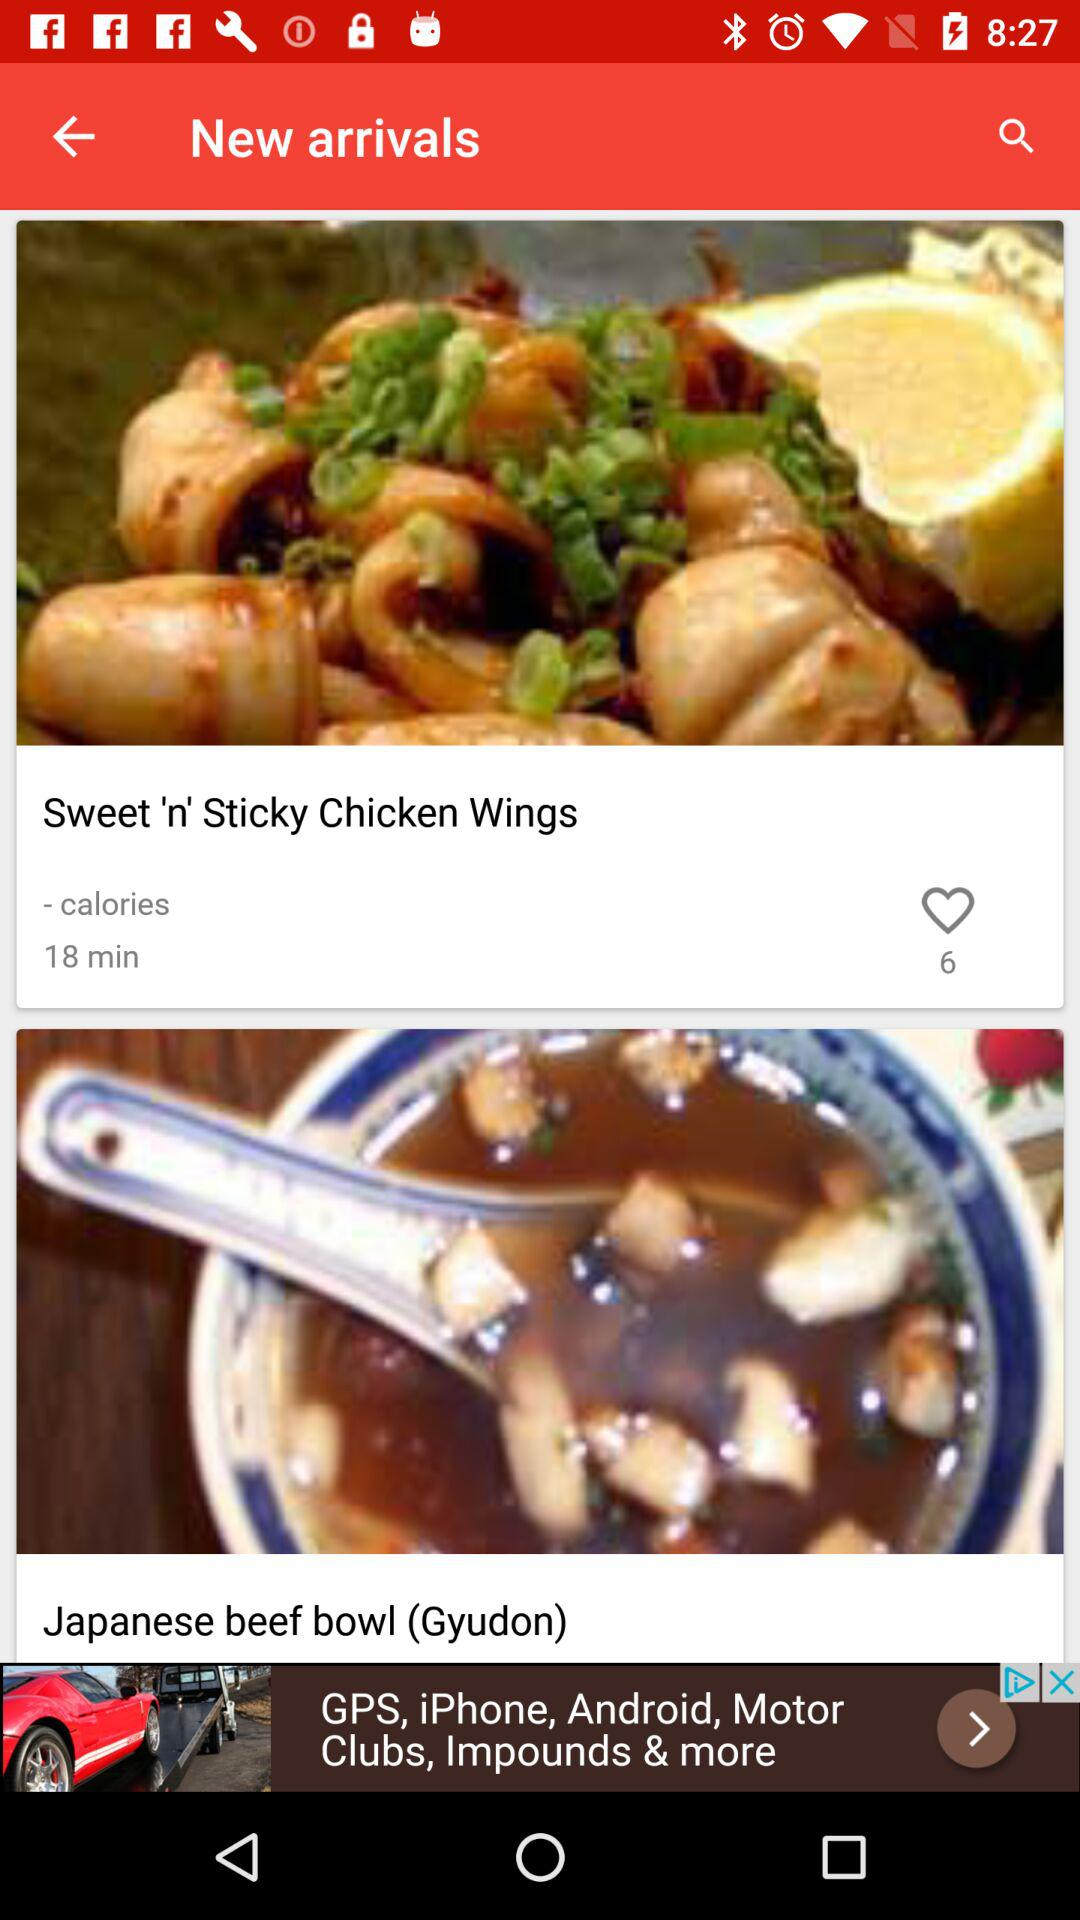When was the new dish updated? The new dish was updated 18 minutes ago. 